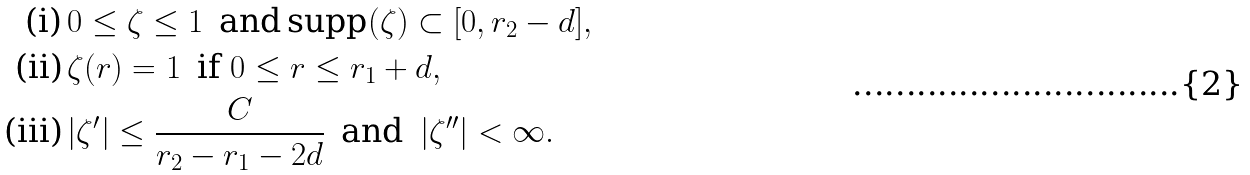Convert formula to latex. <formula><loc_0><loc_0><loc_500><loc_500>\text {(i)} & \, 0 \leq \zeta \leq 1 \, \text { and} \, \text {supp} ( \zeta ) \subset [ 0 , r _ { 2 } - d ] , \\ \text {(ii)} & \, \zeta ( r ) = 1 \, \text { if } 0 \leq r \leq r _ { 1 } + d , \\ \text {(iii)} & \, | \zeta ^ { \prime } | \leq \frac { C } { r _ { 2 } - r _ { 1 } - 2 d } \, \text { and } \, | \zeta ^ { \prime \prime } | < \infty .</formula> 